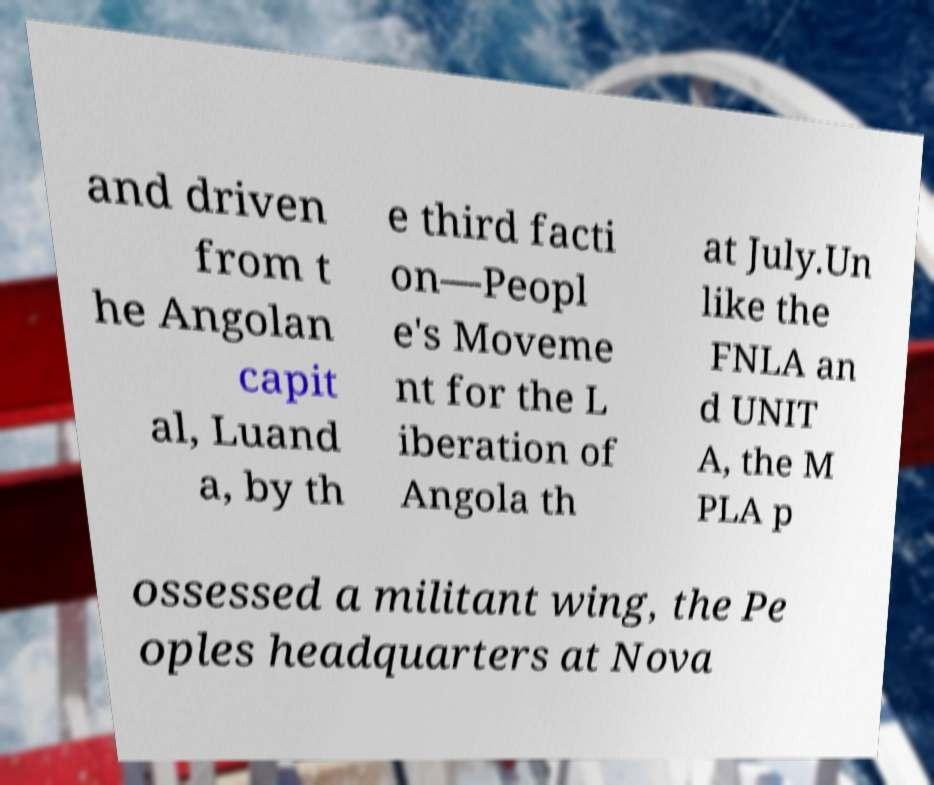Please read and relay the text visible in this image. What does it say? and driven from t he Angolan capit al, Luand a, by th e third facti on—Peopl e's Moveme nt for the L iberation of Angola th at July.Un like the FNLA an d UNIT A, the M PLA p ossessed a militant wing, the Pe oples headquarters at Nova 